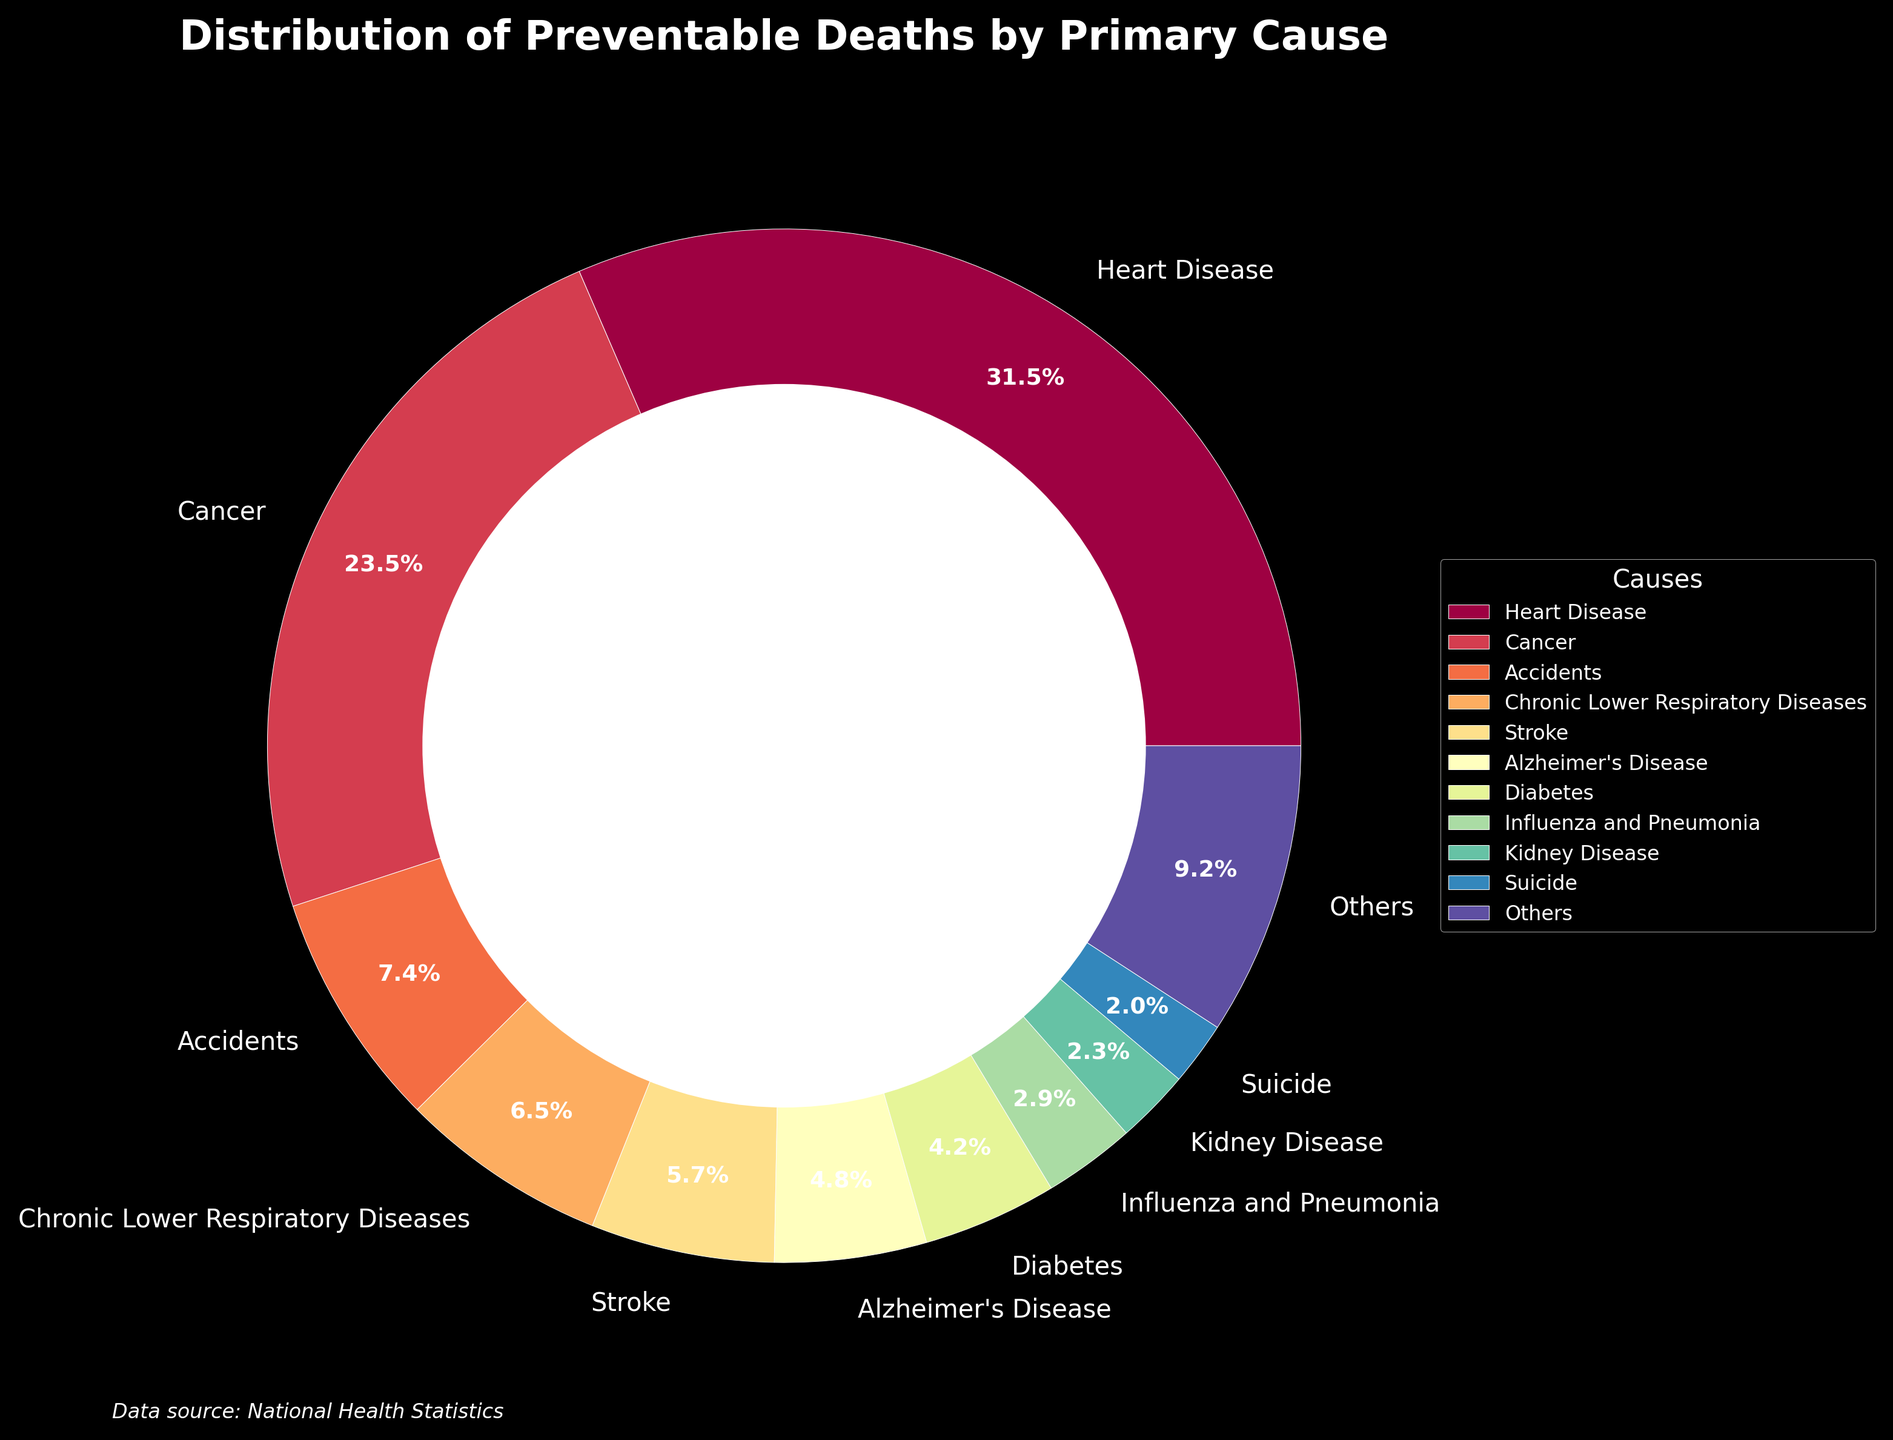What's the largest primary cause of preventable deaths in the country? The chart shows the percentage distribution of preventable deaths by various causes. Heart Disease has the largest slice which is indicated by its segment taking up the largest portion of the pie chart, totaling 28.5%.
Answer: Heart Disease What is the total percentage of deaths caused by Cancer and Stroke combined? From the chart, Cancer accounts for 21.3% and Stroke accounts for 5.2%. Summing these percentages: 21.3 + 5.2 = 26.5%.
Answer: 26.5% How does the percentage of deaths due to Accidents compare to those due to Influenza and Pneumonia? The chart shows that Accidents account for 6.7% while Influenza and Pneumonia account for 2.6%. Thus, Accidents have a higher percentage compared to Influenza and Pneumonia.
Answer: Accidents have a higher percentage Which primary cause of preventable deaths has the second lowest percentage, and what is that percentage? From the chart, we can observe that Vaccine-preventable Diseases have the lowest at 0.3%. Next to the lowest is Alcohol-related Deaths at 0.4%.
Answer: Alcohol-related Deaths, 0.4% What is the total percentage of deaths caused by the top three primary causes? The top three primary causes from the chart are Heart Disease (28.5%), Cancer (21.3%), and Accidents (6.7%). Summing these gives: 28.5 + 21.3 + 6.7 = 56.5%.
Answer: 56.5% Compare the combined percentage of deaths due to Diabetes, Hypertension, and Obesity-related Complications to those from Chronic Lower Respiratory Diseases. Which is higher? Diabetes accounts for 3.8%, Hypertension for 1.2%, and Obesity-related Complications for 0.6%. Summing these gives: 3.8 + 1.2 + 0.6 = 5.6%. Chronic Lower Respiratory Diseases alone account for 5.9%. Thus, deaths from Chronic Lower Respiratory Diseases are higher.
Answer: Chronic Lower Respiratory Diseases What percentage of preventable deaths does ‘Others’ account for in the figure? The category ‘Others’ is summed from all causes not in the top 10. Visual inspection reveals a smaller but significant portion, which can be deduced to be 15.1% (adding up smaller percentages below the top 10 and confirming with visual slice estimation).
Answer: 15.1% Between Alzheimer's Disease and Septicemia, which cause leads to a higher percentage of preventable deaths and by how much? The chart shows Alzheimer's Disease at 4.3% and Septicemia at 1.4%. The difference is 4.3 - 1.4 = 2.9%. Therefore, Alzheimer's Disease leads by 2.9%.
Answer: Alzheimer's Disease by 2.9% What is the least cause of preventable deaths and what percentage does it represent? The figure indicates that Vaccine-preventable Diseases account for the smallest percentage at 0.3%.
Answer: Vaccine-preventable Diseases, 0.3% 